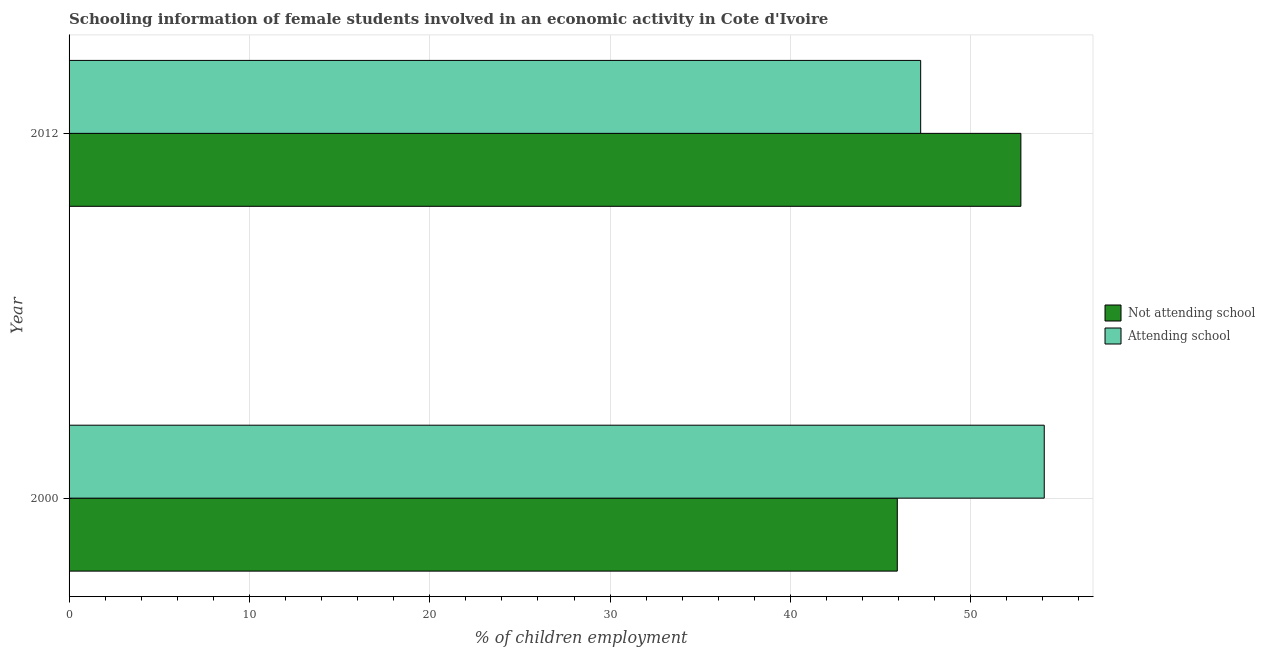How many groups of bars are there?
Give a very brief answer. 2. Are the number of bars on each tick of the Y-axis equal?
Keep it short and to the point. Yes. How many bars are there on the 1st tick from the top?
Your response must be concise. 2. What is the percentage of employed females who are attending school in 2000?
Offer a very short reply. 54.07. Across all years, what is the maximum percentage of employed females who are attending school?
Ensure brevity in your answer.  54.07. Across all years, what is the minimum percentage of employed females who are not attending school?
Keep it short and to the point. 45.93. What is the total percentage of employed females who are not attending school in the graph?
Offer a very short reply. 98.7. What is the difference between the percentage of employed females who are attending school in 2000 and that in 2012?
Make the answer very short. 6.85. What is the difference between the percentage of employed females who are not attending school in 2000 and the percentage of employed females who are attending school in 2012?
Make the answer very short. -1.3. What is the average percentage of employed females who are attending school per year?
Offer a very short reply. 50.65. In the year 2000, what is the difference between the percentage of employed females who are attending school and percentage of employed females who are not attending school?
Your answer should be very brief. 8.15. In how many years, is the percentage of employed females who are attending school greater than 34 %?
Your response must be concise. 2. What is the ratio of the percentage of employed females who are attending school in 2000 to that in 2012?
Make the answer very short. 1.15. What does the 2nd bar from the top in 2012 represents?
Provide a succinct answer. Not attending school. What does the 1st bar from the bottom in 2012 represents?
Give a very brief answer. Not attending school. How many years are there in the graph?
Offer a very short reply. 2. Are the values on the major ticks of X-axis written in scientific E-notation?
Keep it short and to the point. No. Does the graph contain any zero values?
Make the answer very short. No. Does the graph contain grids?
Your response must be concise. Yes. How many legend labels are there?
Your answer should be compact. 2. How are the legend labels stacked?
Give a very brief answer. Vertical. What is the title of the graph?
Your response must be concise. Schooling information of female students involved in an economic activity in Cote d'Ivoire. What is the label or title of the X-axis?
Offer a terse response. % of children employment. What is the % of children employment in Not attending school in 2000?
Keep it short and to the point. 45.93. What is the % of children employment of Attending school in 2000?
Provide a short and direct response. 54.07. What is the % of children employment of Not attending school in 2012?
Provide a succinct answer. 52.78. What is the % of children employment in Attending school in 2012?
Provide a short and direct response. 47.22. Across all years, what is the maximum % of children employment of Not attending school?
Provide a short and direct response. 52.78. Across all years, what is the maximum % of children employment of Attending school?
Offer a very short reply. 54.07. Across all years, what is the minimum % of children employment of Not attending school?
Your answer should be compact. 45.93. Across all years, what is the minimum % of children employment in Attending school?
Provide a succinct answer. 47.22. What is the total % of children employment of Not attending school in the graph?
Give a very brief answer. 98.7. What is the total % of children employment of Attending school in the graph?
Offer a very short reply. 101.3. What is the difference between the % of children employment of Not attending school in 2000 and that in 2012?
Offer a terse response. -6.85. What is the difference between the % of children employment in Attending school in 2000 and that in 2012?
Offer a very short reply. 6.85. What is the difference between the % of children employment of Not attending school in 2000 and the % of children employment of Attending school in 2012?
Provide a short and direct response. -1.3. What is the average % of children employment in Not attending school per year?
Offer a terse response. 49.35. What is the average % of children employment in Attending school per year?
Keep it short and to the point. 50.65. In the year 2000, what is the difference between the % of children employment in Not attending school and % of children employment in Attending school?
Ensure brevity in your answer.  -8.15. In the year 2012, what is the difference between the % of children employment of Not attending school and % of children employment of Attending school?
Provide a succinct answer. 5.56. What is the ratio of the % of children employment in Not attending school in 2000 to that in 2012?
Offer a terse response. 0.87. What is the ratio of the % of children employment of Attending school in 2000 to that in 2012?
Provide a short and direct response. 1.15. What is the difference between the highest and the second highest % of children employment in Not attending school?
Provide a short and direct response. 6.85. What is the difference between the highest and the second highest % of children employment of Attending school?
Offer a terse response. 6.85. What is the difference between the highest and the lowest % of children employment in Not attending school?
Make the answer very short. 6.85. What is the difference between the highest and the lowest % of children employment of Attending school?
Give a very brief answer. 6.85. 